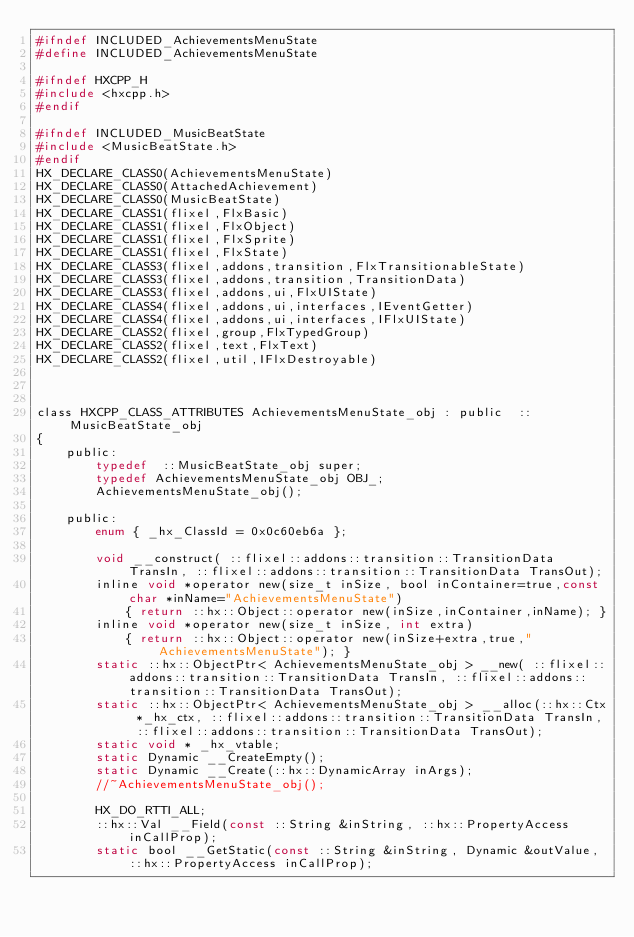Convert code to text. <code><loc_0><loc_0><loc_500><loc_500><_C_>#ifndef INCLUDED_AchievementsMenuState
#define INCLUDED_AchievementsMenuState

#ifndef HXCPP_H
#include <hxcpp.h>
#endif

#ifndef INCLUDED_MusicBeatState
#include <MusicBeatState.h>
#endif
HX_DECLARE_CLASS0(AchievementsMenuState)
HX_DECLARE_CLASS0(AttachedAchievement)
HX_DECLARE_CLASS0(MusicBeatState)
HX_DECLARE_CLASS1(flixel,FlxBasic)
HX_DECLARE_CLASS1(flixel,FlxObject)
HX_DECLARE_CLASS1(flixel,FlxSprite)
HX_DECLARE_CLASS1(flixel,FlxState)
HX_DECLARE_CLASS3(flixel,addons,transition,FlxTransitionableState)
HX_DECLARE_CLASS3(flixel,addons,transition,TransitionData)
HX_DECLARE_CLASS3(flixel,addons,ui,FlxUIState)
HX_DECLARE_CLASS4(flixel,addons,ui,interfaces,IEventGetter)
HX_DECLARE_CLASS4(flixel,addons,ui,interfaces,IFlxUIState)
HX_DECLARE_CLASS2(flixel,group,FlxTypedGroup)
HX_DECLARE_CLASS2(flixel,text,FlxText)
HX_DECLARE_CLASS2(flixel,util,IFlxDestroyable)



class HXCPP_CLASS_ATTRIBUTES AchievementsMenuState_obj : public  ::MusicBeatState_obj
{
	public:
		typedef  ::MusicBeatState_obj super;
		typedef AchievementsMenuState_obj OBJ_;
		AchievementsMenuState_obj();

	public:
		enum { _hx_ClassId = 0x0c60eb6a };

		void __construct( ::flixel::addons::transition::TransitionData TransIn, ::flixel::addons::transition::TransitionData TransOut);
		inline void *operator new(size_t inSize, bool inContainer=true,const char *inName="AchievementsMenuState")
			{ return ::hx::Object::operator new(inSize,inContainer,inName); }
		inline void *operator new(size_t inSize, int extra)
			{ return ::hx::Object::operator new(inSize+extra,true,"AchievementsMenuState"); }
		static ::hx::ObjectPtr< AchievementsMenuState_obj > __new( ::flixel::addons::transition::TransitionData TransIn, ::flixel::addons::transition::TransitionData TransOut);
		static ::hx::ObjectPtr< AchievementsMenuState_obj > __alloc(::hx::Ctx *_hx_ctx, ::flixel::addons::transition::TransitionData TransIn, ::flixel::addons::transition::TransitionData TransOut);
		static void * _hx_vtable;
		static Dynamic __CreateEmpty();
		static Dynamic __Create(::hx::DynamicArray inArgs);
		//~AchievementsMenuState_obj();

		HX_DO_RTTI_ALL;
		::hx::Val __Field(const ::String &inString, ::hx::PropertyAccess inCallProp);
		static bool __GetStatic(const ::String &inString, Dynamic &outValue, ::hx::PropertyAccess inCallProp);</code> 